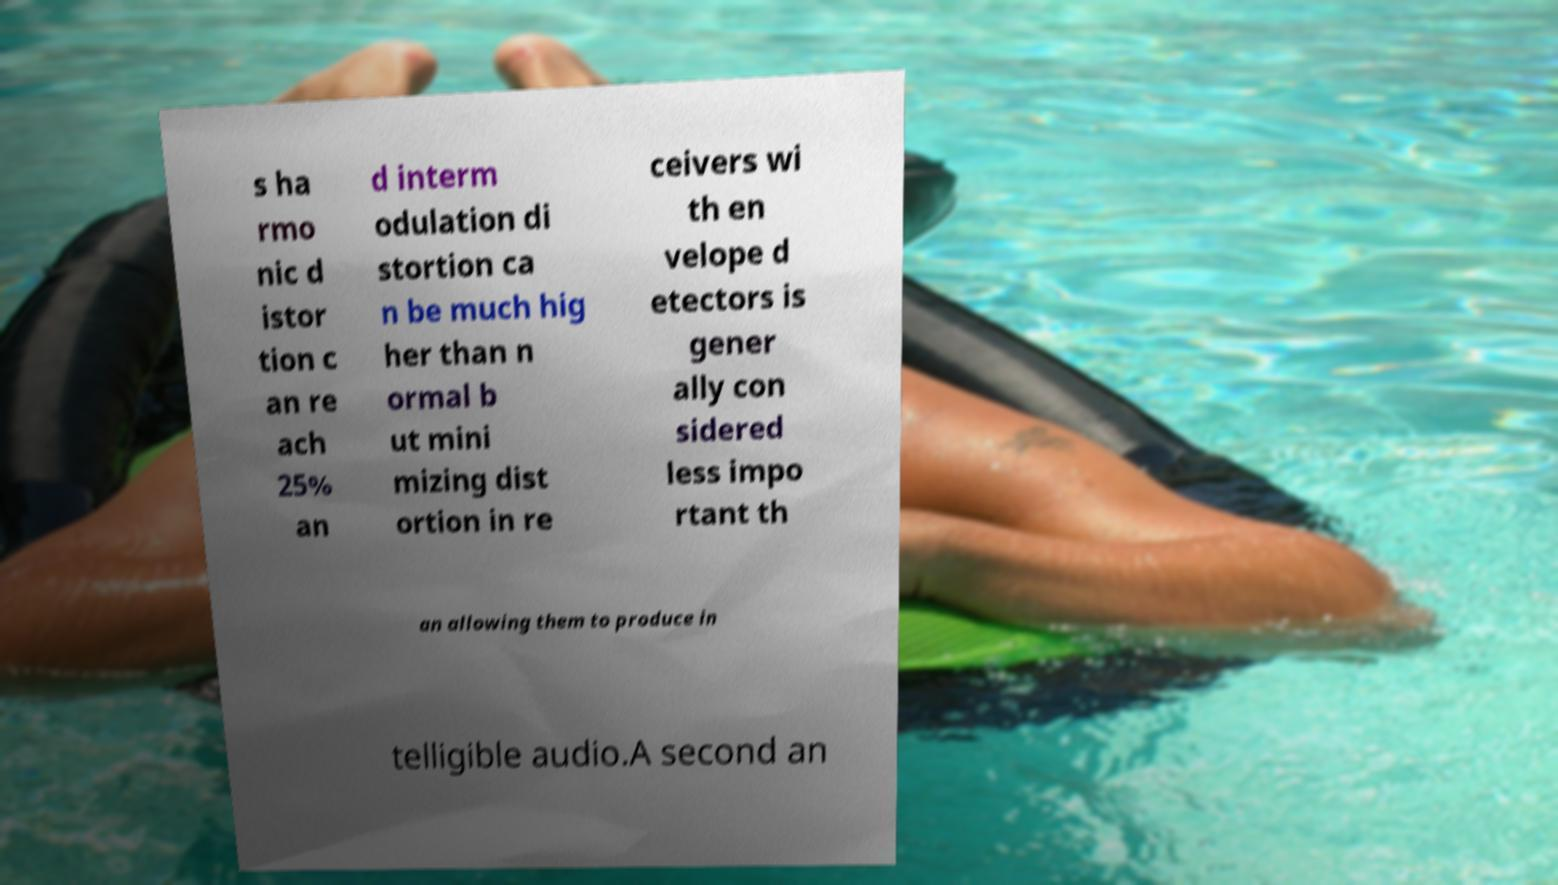Please identify and transcribe the text found in this image. s ha rmo nic d istor tion c an re ach 25% an d interm odulation di stortion ca n be much hig her than n ormal b ut mini mizing dist ortion in re ceivers wi th en velope d etectors is gener ally con sidered less impo rtant th an allowing them to produce in telligible audio.A second an 